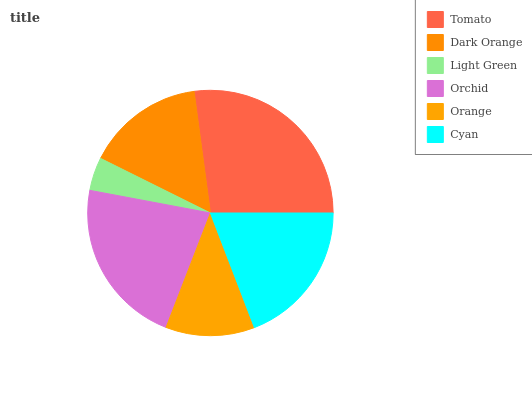Is Light Green the minimum?
Answer yes or no. Yes. Is Tomato the maximum?
Answer yes or no. Yes. Is Dark Orange the minimum?
Answer yes or no. No. Is Dark Orange the maximum?
Answer yes or no. No. Is Tomato greater than Dark Orange?
Answer yes or no. Yes. Is Dark Orange less than Tomato?
Answer yes or no. Yes. Is Dark Orange greater than Tomato?
Answer yes or no. No. Is Tomato less than Dark Orange?
Answer yes or no. No. Is Cyan the high median?
Answer yes or no. Yes. Is Dark Orange the low median?
Answer yes or no. Yes. Is Orange the high median?
Answer yes or no. No. Is Tomato the low median?
Answer yes or no. No. 